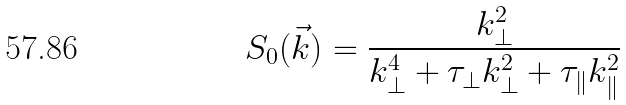<formula> <loc_0><loc_0><loc_500><loc_500>S _ { 0 } ( \vec { k } ) = \frac { k _ { \bot } ^ { 2 } } { k _ { \bot } ^ { 4 } + \tau _ { \bot } k _ { \bot } ^ { 2 } + \tau _ { \| } k _ { \| } ^ { 2 } }</formula> 